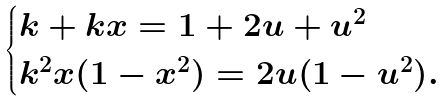<formula> <loc_0><loc_0><loc_500><loc_500>\begin{cases} k + k x = 1 + 2 u + u ^ { 2 } \\ k ^ { 2 } x ( 1 - x ^ { 2 } ) = 2 u ( 1 - u ^ { 2 } ) . \end{cases}</formula> 